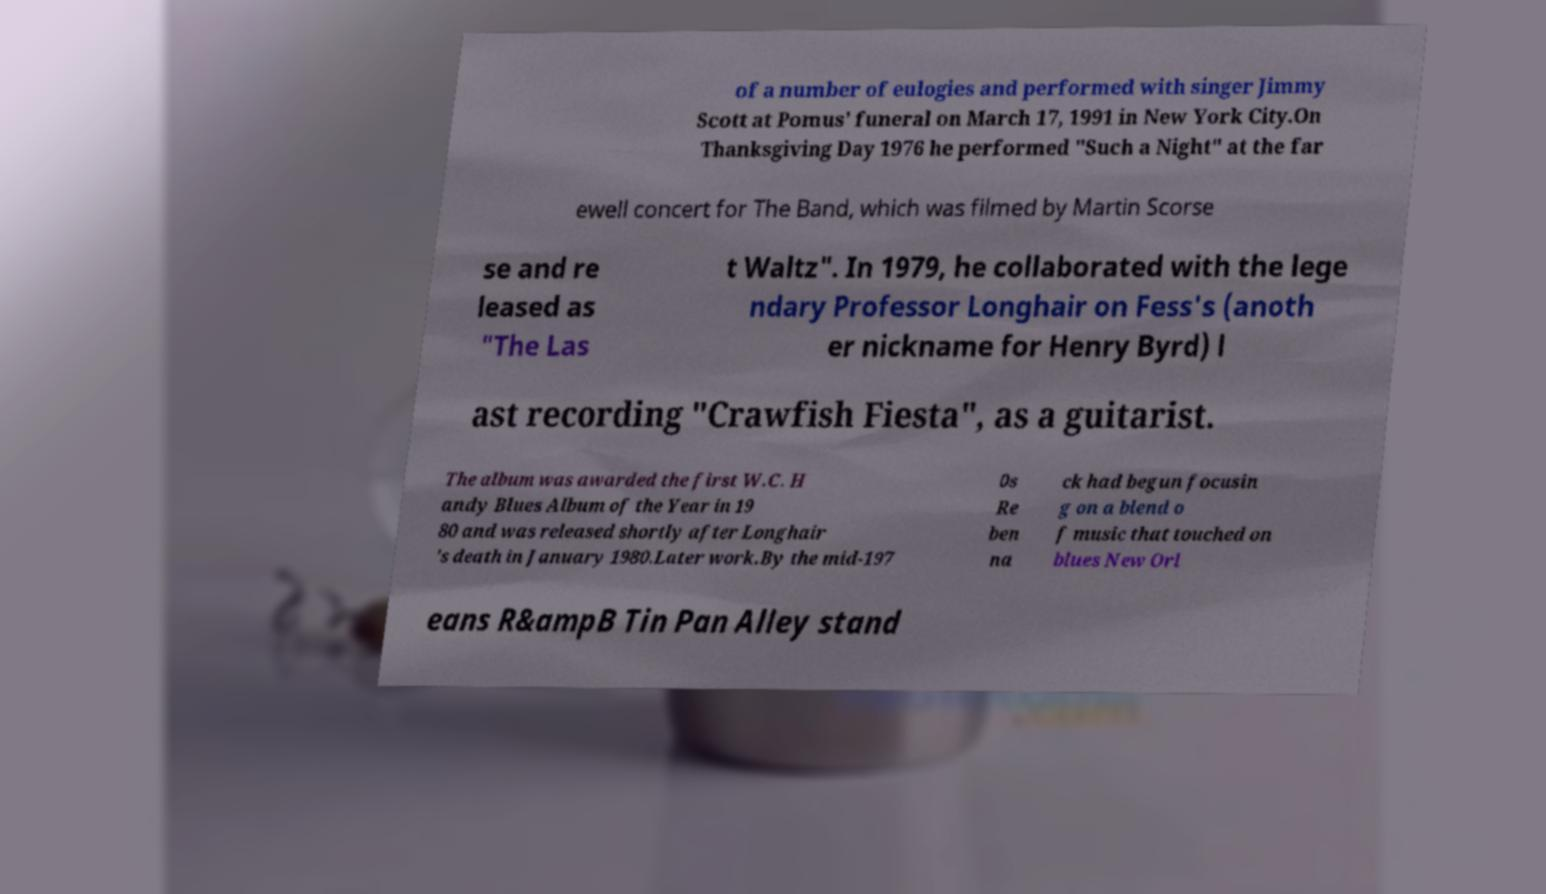For documentation purposes, I need the text within this image transcribed. Could you provide that? of a number of eulogies and performed with singer Jimmy Scott at Pomus' funeral on March 17, 1991 in New York City.On Thanksgiving Day 1976 he performed "Such a Night" at the far ewell concert for The Band, which was filmed by Martin Scorse se and re leased as "The Las t Waltz". In 1979, he collaborated with the lege ndary Professor Longhair on Fess's (anoth er nickname for Henry Byrd) l ast recording "Crawfish Fiesta", as a guitarist. The album was awarded the first W.C. H andy Blues Album of the Year in 19 80 and was released shortly after Longhair 's death in January 1980.Later work.By the mid-197 0s Re ben na ck had begun focusin g on a blend o f music that touched on blues New Orl eans R&ampB Tin Pan Alley stand 